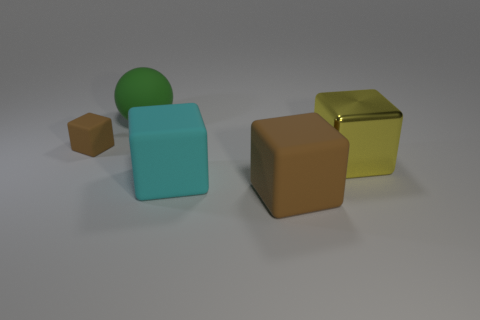Subtract all purple cubes. Subtract all brown spheres. How many cubes are left? 4 Add 3 tiny brown blocks. How many objects exist? 8 Subtract all spheres. How many objects are left? 4 Subtract all blocks. Subtract all yellow blocks. How many objects are left? 0 Add 5 blocks. How many blocks are left? 9 Add 3 brown cylinders. How many brown cylinders exist? 3 Subtract 0 yellow cylinders. How many objects are left? 5 